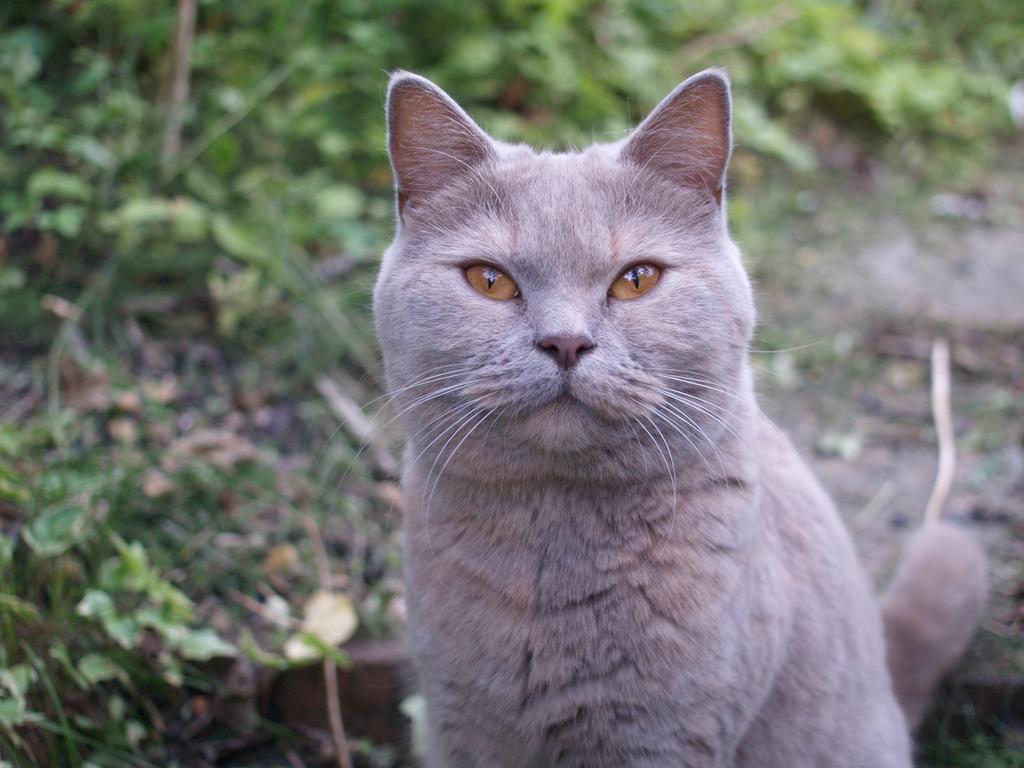Can you describe this image briefly? In the center of the image, we can see a cat and in the background, there are trees. 